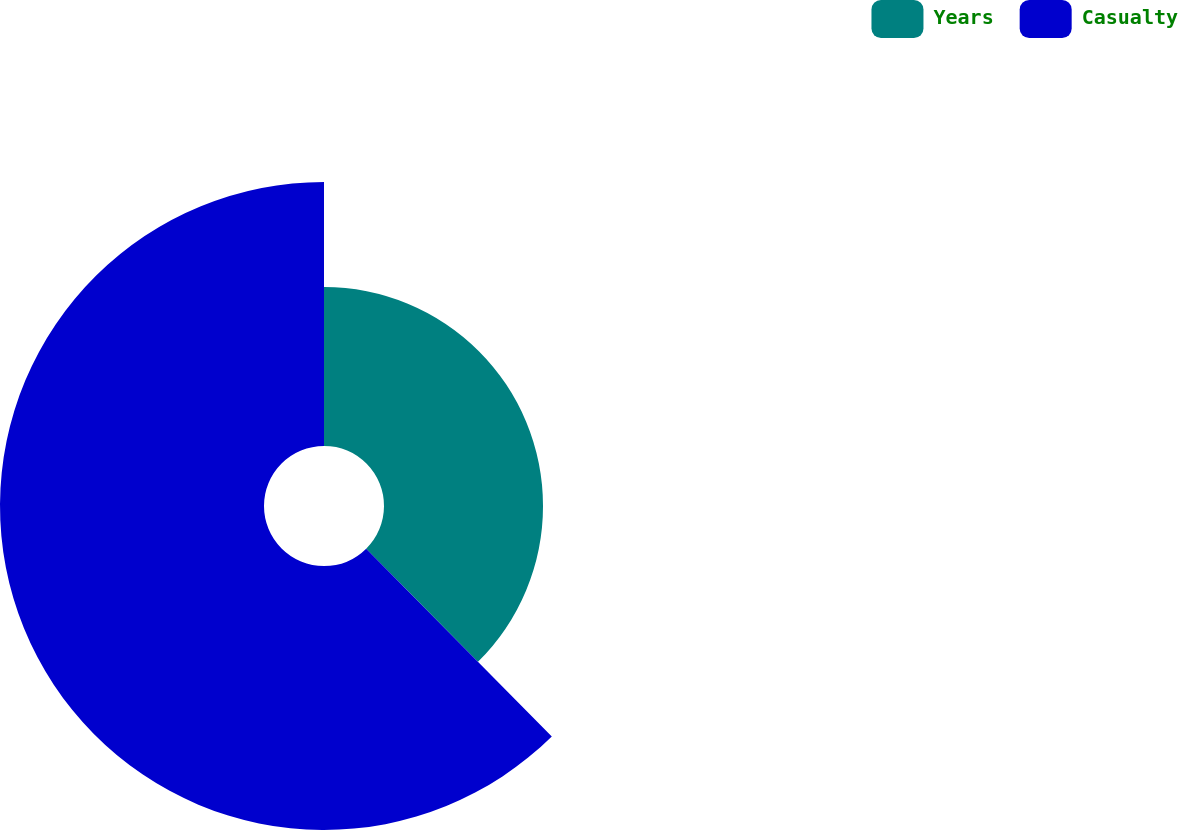Convert chart. <chart><loc_0><loc_0><loc_500><loc_500><pie_chart><fcel>Years<fcel>Casualty<nl><fcel>37.59%<fcel>62.41%<nl></chart> 